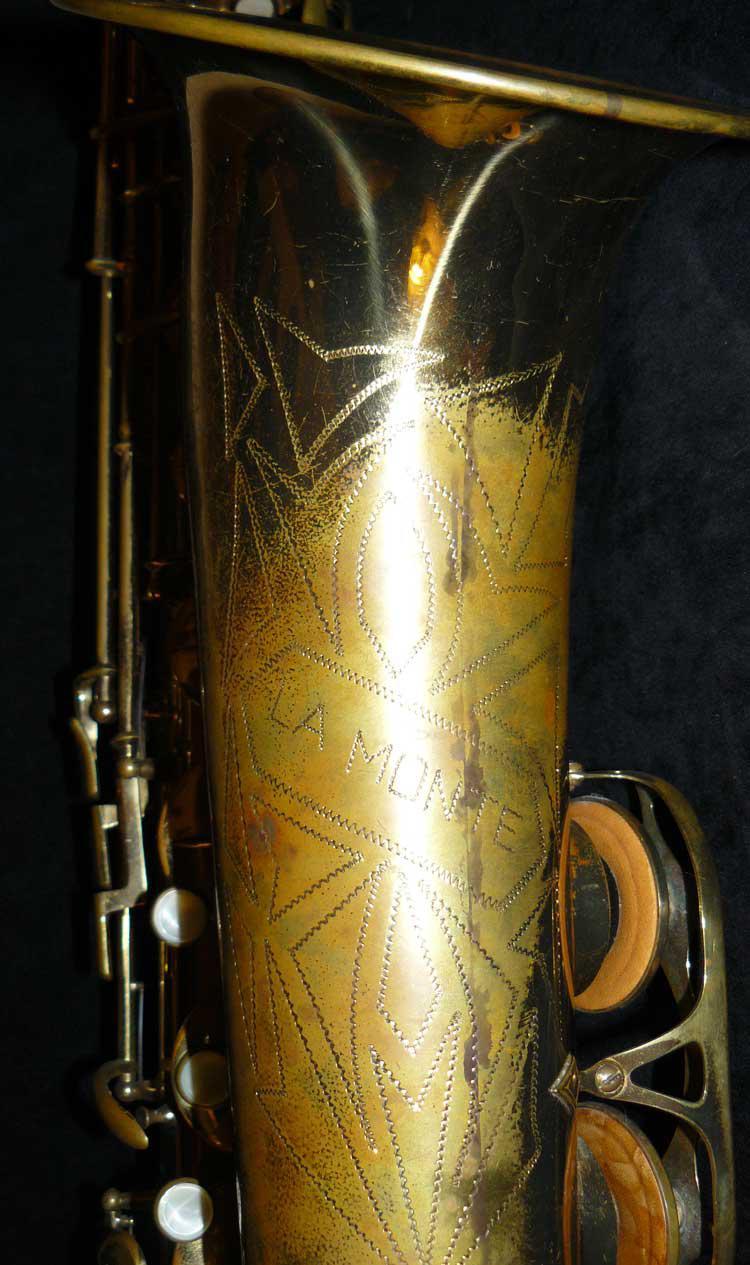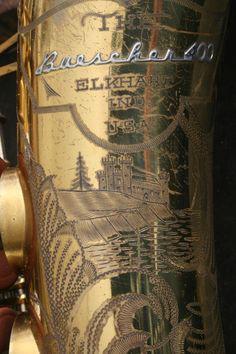The first image is the image on the left, the second image is the image on the right. Given the left and right images, does the statement "In at least one image, the close up picture reveals text that has been engraved into the saxophone." hold true? Answer yes or no. Yes. 